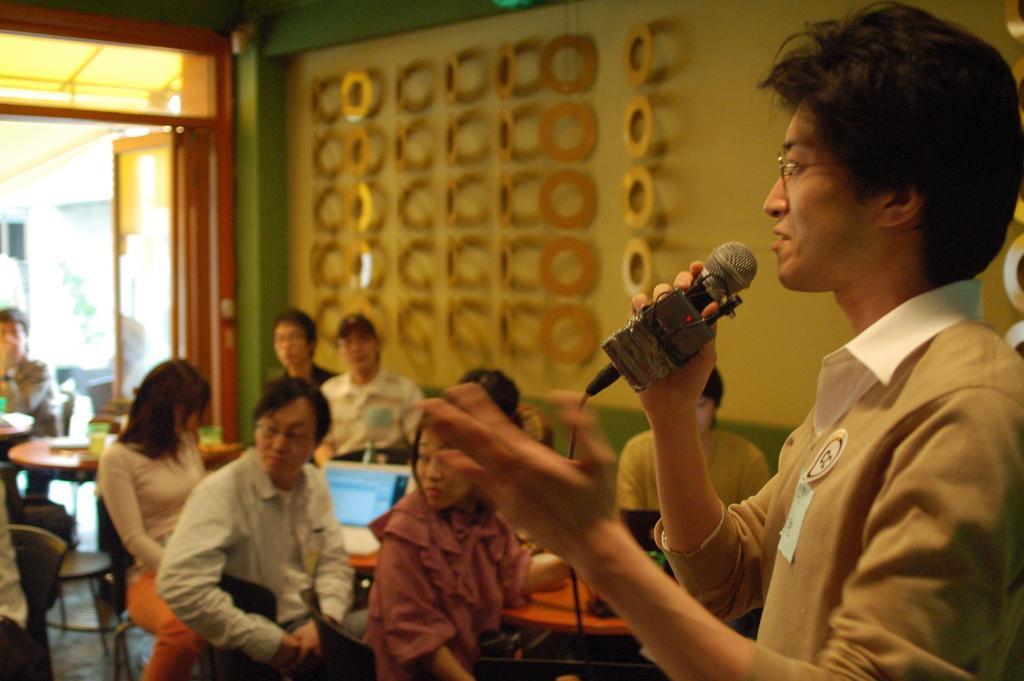Please provide a concise description of this image. In the bottom right corner of the image a person is standing and holding a microphone. Behind him few people are sitting on chairs and there are some tables, on the tables there are some glasses, bottles and laptops. Behind them there is wall and door. 